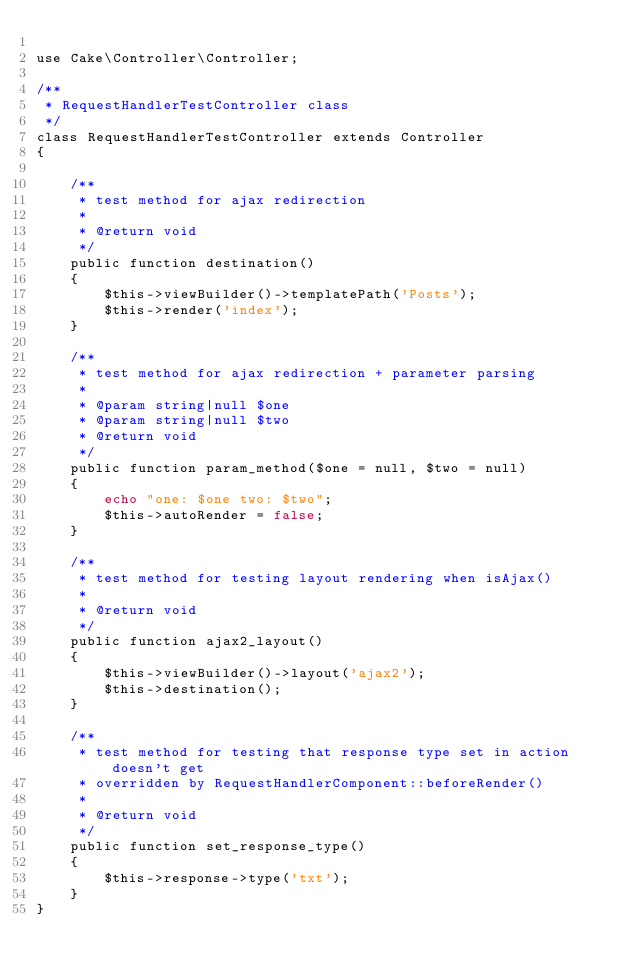<code> <loc_0><loc_0><loc_500><loc_500><_PHP_>
use Cake\Controller\Controller;

/**
 * RequestHandlerTestController class
 */
class RequestHandlerTestController extends Controller
{

    /**
     * test method for ajax redirection
     *
     * @return void
     */
    public function destination()
    {
        $this->viewBuilder()->templatePath('Posts');
        $this->render('index');
    }

    /**
     * test method for ajax redirection + parameter parsing
     *
     * @param string|null $one
     * @param string|null $two
     * @return void
     */
    public function param_method($one = null, $two = null)
    {
        echo "one: $one two: $two";
        $this->autoRender = false;
    }

    /**
     * test method for testing layout rendering when isAjax()
     *
     * @return void
     */
    public function ajax2_layout()
    {
        $this->viewBuilder()->layout('ajax2');
        $this->destination();
    }

    /**
     * test method for testing that response type set in action doesn't get
     * overridden by RequestHandlerComponent::beforeRender()
     *
     * @return void
     */
    public function set_response_type()
    {
        $this->response->type('txt');
    }
}
</code> 